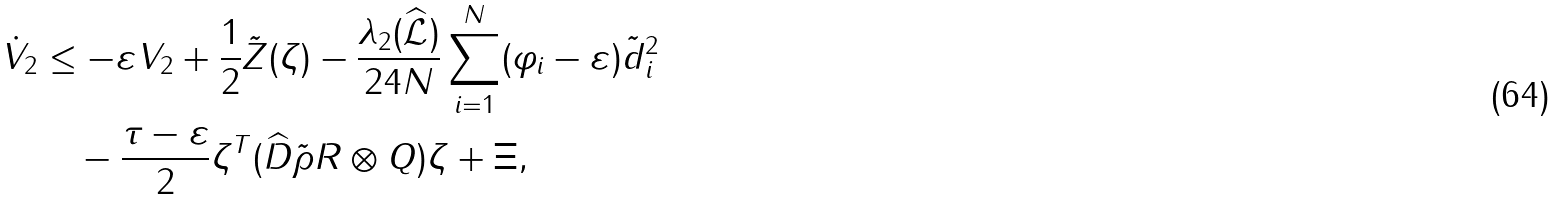Convert formula to latex. <formula><loc_0><loc_0><loc_500><loc_500>\dot { V } _ { 2 } & \leq - \varepsilon V _ { 2 } + \frac { 1 } { 2 } \tilde { Z } ( \zeta ) - \frac { \lambda _ { 2 } ( \widehat { \mathcal { L } } ) } { 2 4 N } \sum _ { i = 1 } ^ { N } ( \varphi _ { i } - \varepsilon ) \tilde { d } _ { i } ^ { 2 } \\ & \quad - \frac { \tau - \varepsilon } { 2 } \zeta ^ { T } ( \widehat { D } \tilde { \rho } R \otimes Q ) \zeta + \Xi ,</formula> 